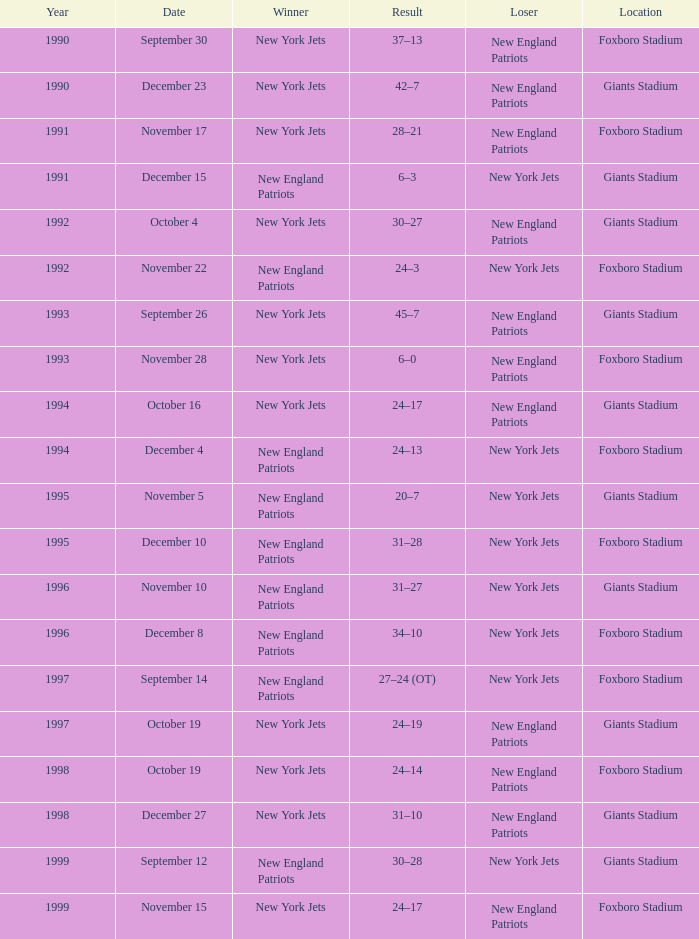Can you give me this table as a dict? {'header': ['Year', 'Date', 'Winner', 'Result', 'Loser', 'Location'], 'rows': [['1990', 'September 30', 'New York Jets', '37–13', 'New England Patriots', 'Foxboro Stadium'], ['1990', 'December 23', 'New York Jets', '42–7', 'New England Patriots', 'Giants Stadium'], ['1991', 'November 17', 'New York Jets', '28–21', 'New England Patriots', 'Foxboro Stadium'], ['1991', 'December 15', 'New England Patriots', '6–3', 'New York Jets', 'Giants Stadium'], ['1992', 'October 4', 'New York Jets', '30–27', 'New England Patriots', 'Giants Stadium'], ['1992', 'November 22', 'New England Patriots', '24–3', 'New York Jets', 'Foxboro Stadium'], ['1993', 'September 26', 'New York Jets', '45–7', 'New England Patriots', 'Giants Stadium'], ['1993', 'November 28', 'New York Jets', '6–0', 'New England Patriots', 'Foxboro Stadium'], ['1994', 'October 16', 'New York Jets', '24–17', 'New England Patriots', 'Giants Stadium'], ['1994', 'December 4', 'New England Patriots', '24–13', 'New York Jets', 'Foxboro Stadium'], ['1995', 'November 5', 'New England Patriots', '20–7', 'New York Jets', 'Giants Stadium'], ['1995', 'December 10', 'New England Patriots', '31–28', 'New York Jets', 'Foxboro Stadium'], ['1996', 'November 10', 'New England Patriots', '31–27', 'New York Jets', 'Giants Stadium'], ['1996', 'December 8', 'New England Patriots', '34–10', 'New York Jets', 'Foxboro Stadium'], ['1997', 'September 14', 'New England Patriots', '27–24 (OT)', 'New York Jets', 'Foxboro Stadium'], ['1997', 'October 19', 'New York Jets', '24–19', 'New England Patriots', 'Giants Stadium'], ['1998', 'October 19', 'New York Jets', '24–14', 'New England Patriots', 'Foxboro Stadium'], ['1998', 'December 27', 'New York Jets', '31–10', 'New England Patriots', 'Giants Stadium'], ['1999', 'September 12', 'New England Patriots', '30–28', 'New York Jets', 'Giants Stadium'], ['1999', 'November 15', 'New York Jets', '24–17', 'New England Patriots', 'Foxboro Stadium']]} When the new england patriots won with a score of 30-28 at giants stadium, who was the losing team? New York Jets. 